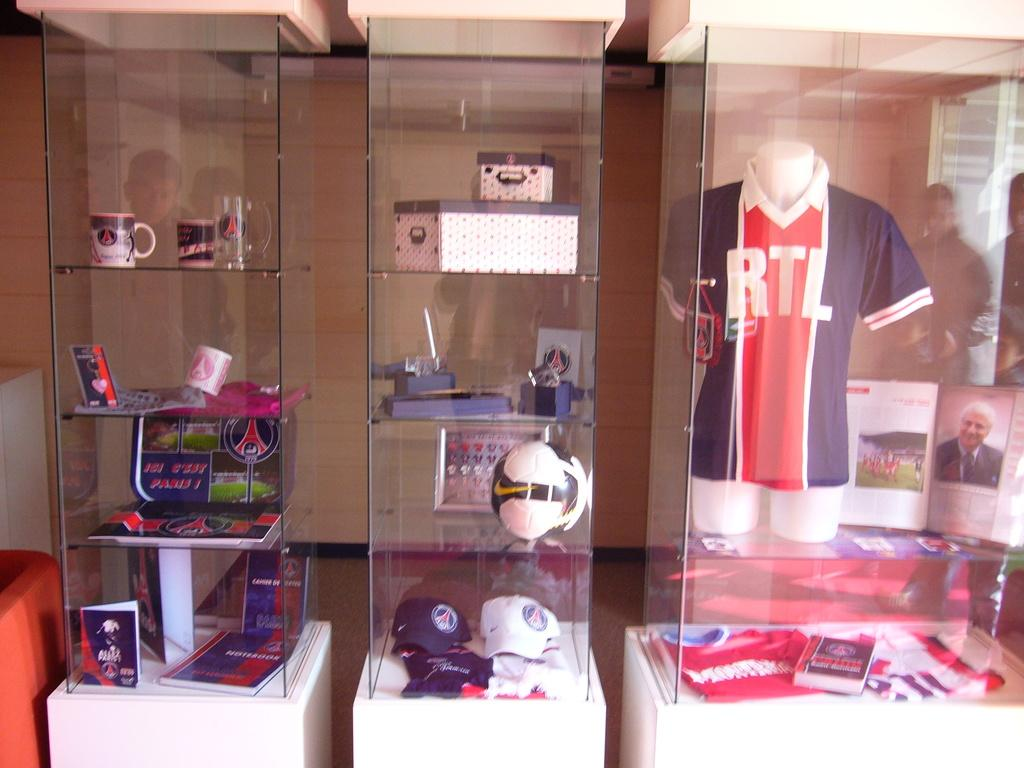<image>
Summarize the visual content of the image. Sports memorabilia such as a jersey with RTL on it is behind glass displays 